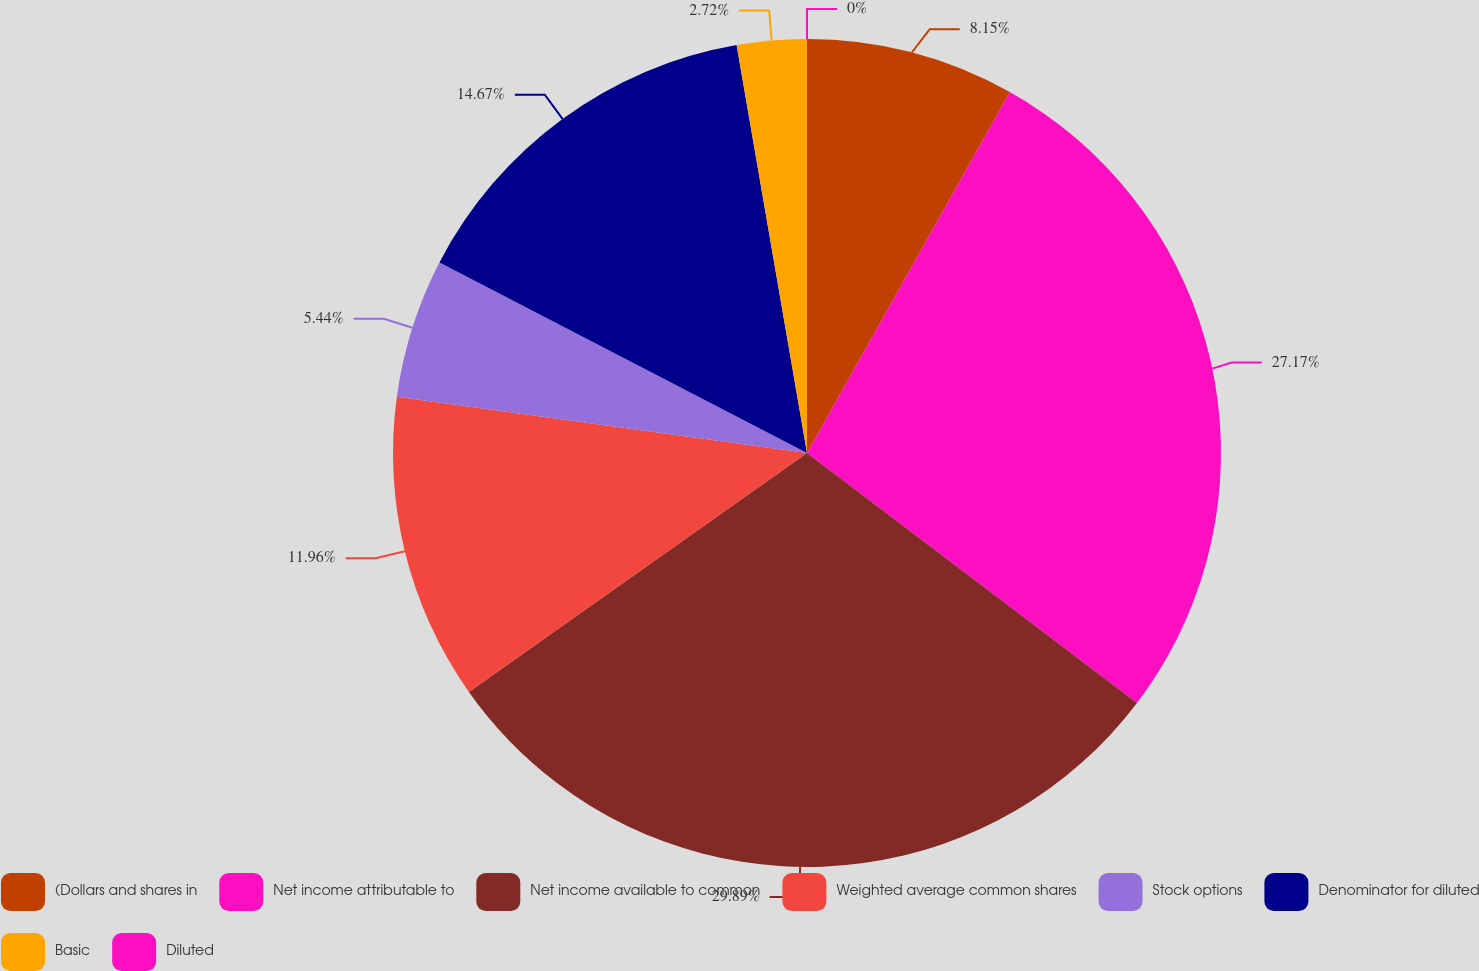<chart> <loc_0><loc_0><loc_500><loc_500><pie_chart><fcel>(Dollars and shares in<fcel>Net income attributable to<fcel>Net income available to common<fcel>Weighted average common shares<fcel>Stock options<fcel>Denominator for diluted<fcel>Basic<fcel>Diluted<nl><fcel>8.15%<fcel>27.17%<fcel>29.89%<fcel>11.96%<fcel>5.44%<fcel>14.67%<fcel>2.72%<fcel>0.0%<nl></chart> 